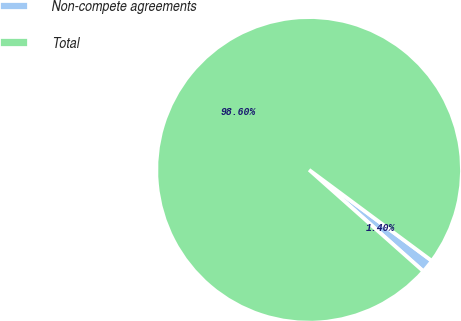<chart> <loc_0><loc_0><loc_500><loc_500><pie_chart><fcel>Non-compete agreements<fcel>Total<nl><fcel>1.4%<fcel>98.6%<nl></chart> 